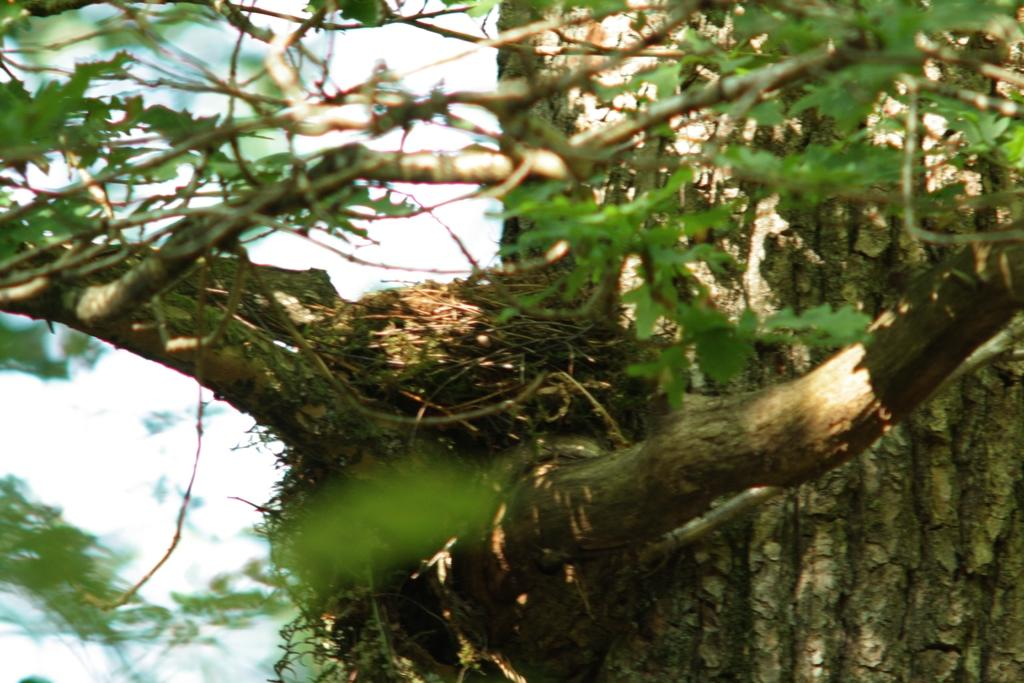What is the main subject in the center of the image? There is a nest in the center of the image. What type of environment is depicted in the image? There is greenery in the image, suggesting a natural or outdoor setting. How much lettuce is present in the image? There is no lettuce present in the image; it features a nest and greenery. What type of financial obligation is depicted in the image? There is no financial obligation or debt depicted in the image; it features a nest and greenery. 